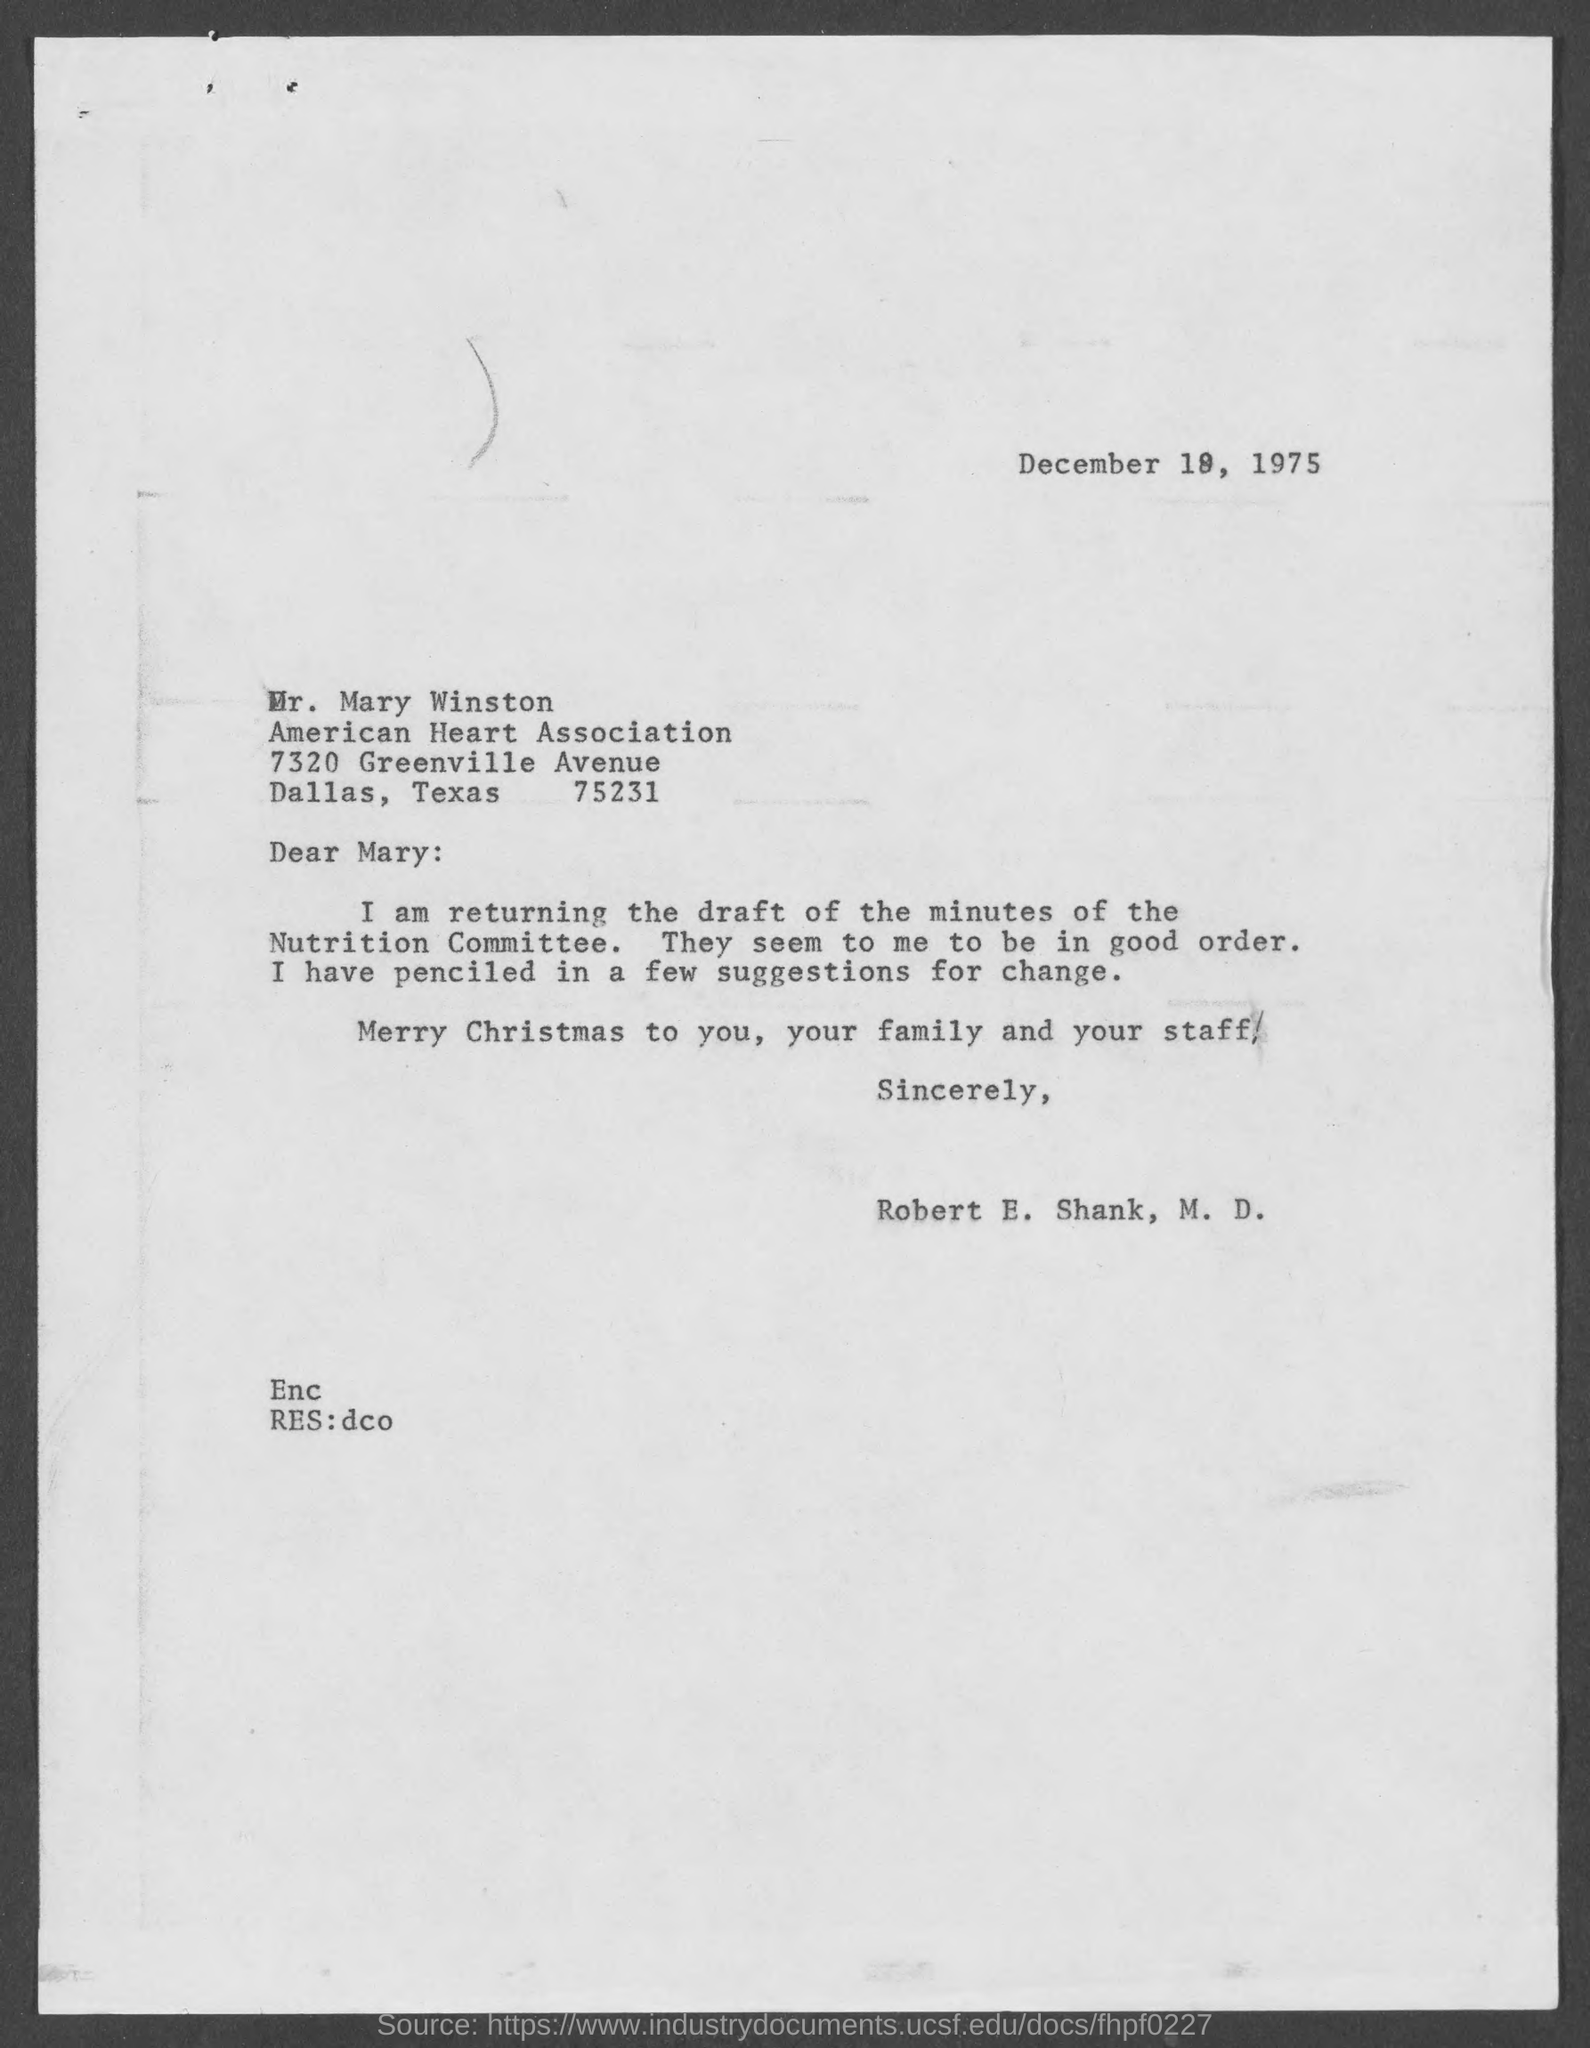Mention a couple of crucial points in this snapshot. The date mentioned is December 19, 1975. 